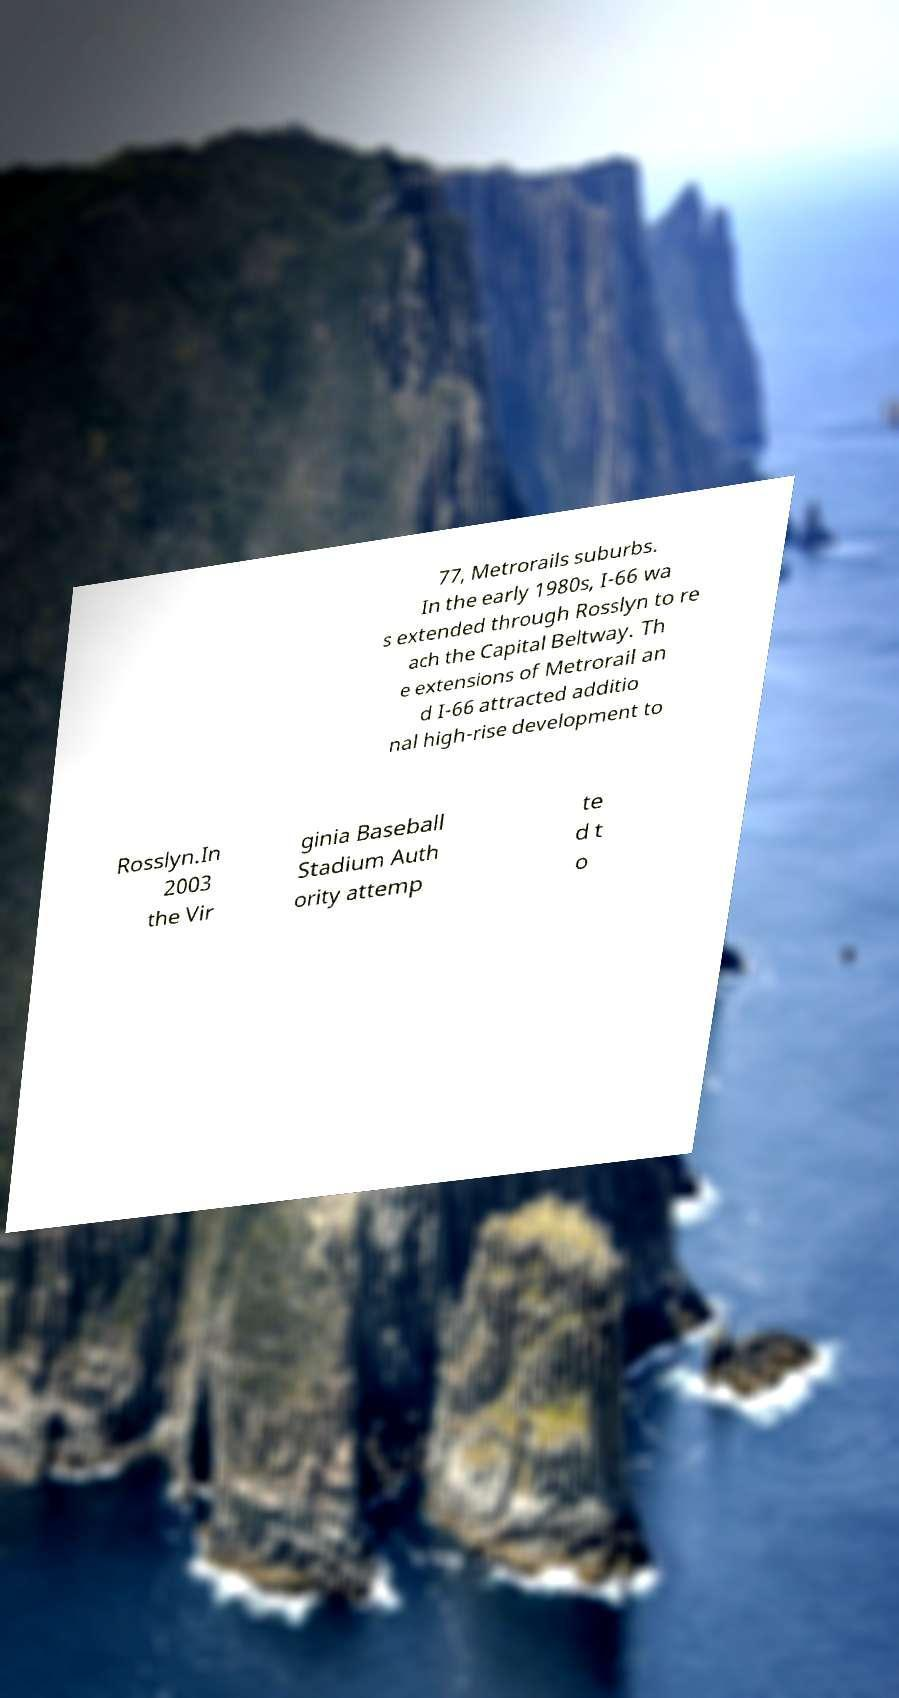Can you read and provide the text displayed in the image?This photo seems to have some interesting text. Can you extract and type it out for me? 77, Metrorails suburbs. In the early 1980s, I-66 wa s extended through Rosslyn to re ach the Capital Beltway. Th e extensions of Metrorail an d I-66 attracted additio nal high-rise development to Rosslyn.In 2003 the Vir ginia Baseball Stadium Auth ority attemp te d t o 